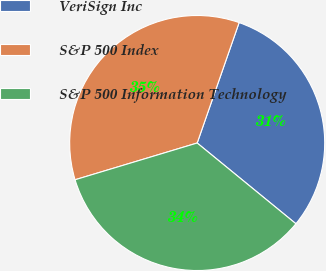Convert chart to OTSL. <chart><loc_0><loc_0><loc_500><loc_500><pie_chart><fcel>VeriSign Inc<fcel>S&P 500 Index<fcel>S&P 500 Information Technology<nl><fcel>30.58%<fcel>34.99%<fcel>34.44%<nl></chart> 